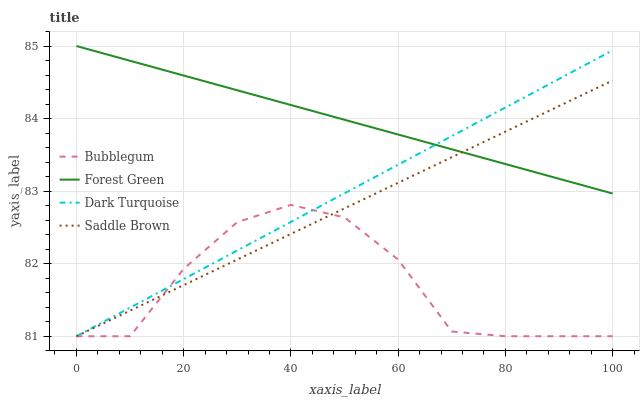Does Saddle Brown have the minimum area under the curve?
Answer yes or no. No. Does Saddle Brown have the maximum area under the curve?
Answer yes or no. No. Is Forest Green the smoothest?
Answer yes or no. No. Is Forest Green the roughest?
Answer yes or no. No. Does Forest Green have the lowest value?
Answer yes or no. No. Does Saddle Brown have the highest value?
Answer yes or no. No. Is Bubblegum less than Forest Green?
Answer yes or no. Yes. Is Forest Green greater than Bubblegum?
Answer yes or no. Yes. Does Bubblegum intersect Forest Green?
Answer yes or no. No. 